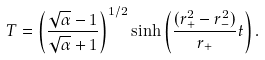Convert formula to latex. <formula><loc_0><loc_0><loc_500><loc_500>T = \left ( \frac { \sqrt { \alpha } - 1 } { \sqrt { \alpha } + 1 } \right ) ^ { 1 / 2 } \sinh \left ( { \frac { ( r _ { + } ^ { 2 } - r _ { - } ^ { 2 } ) } { r _ { + } } } t \right ) .</formula> 